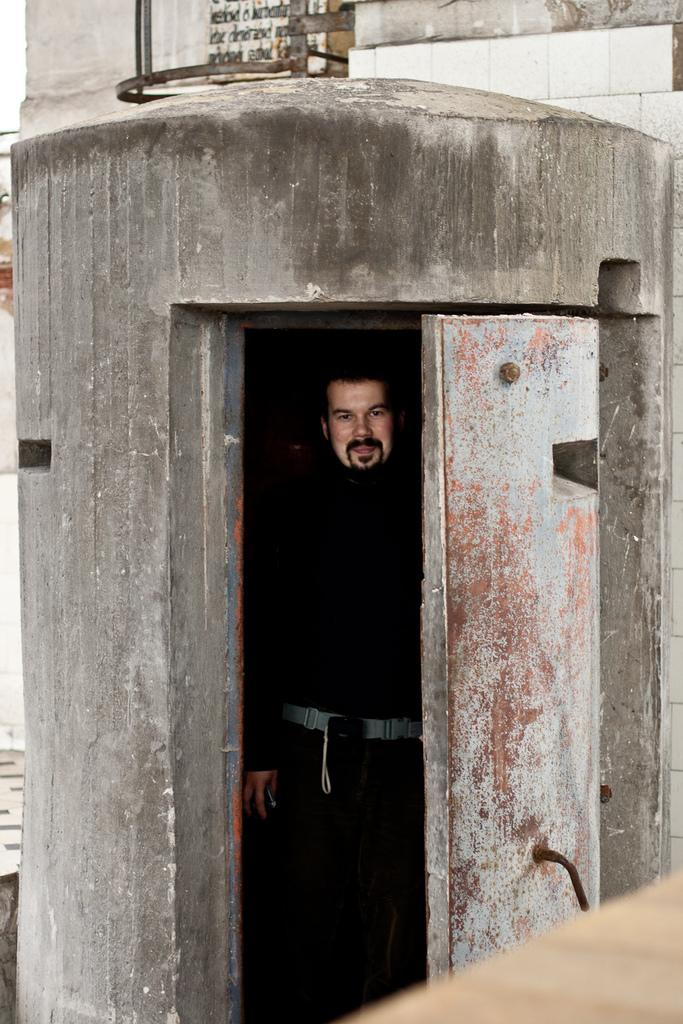What is the main subject of the image? There is a man in the image. What is the man doing in the image? The man is standing in the image. What is the man's facial expression in the image? The man is smiling in the image. What can be seen in the background of the image? There is a wall in the background of the image. What type of insurance does the man need in the image? There is no information about insurance in the image, as it only features a man standing and smiling with a wall in the background. 